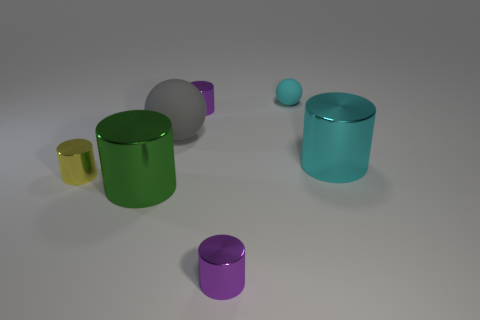What number of tiny things are both behind the big sphere and in front of the tiny rubber ball?
Provide a succinct answer. 1. What is the size of the yellow object that is the same shape as the green thing?
Offer a very short reply. Small. What number of large gray matte spheres are behind the large cylinder to the right of the tiny cylinder that is in front of the tiny yellow cylinder?
Make the answer very short. 1. The small shiny cylinder behind the cyan object that is on the right side of the small cyan matte sphere is what color?
Ensure brevity in your answer.  Purple. What number of other objects are the same material as the tiny cyan thing?
Provide a succinct answer. 1. How many things are behind the small yellow metallic cylinder in front of the big sphere?
Keep it short and to the point. 4. Do the large shiny thing behind the green cylinder and the tiny rubber thing right of the green object have the same color?
Your answer should be very brief. Yes. Are there fewer tiny yellow cylinders than large shiny cylinders?
Make the answer very short. Yes. There is a matte object behind the small cylinder behind the small yellow cylinder; what shape is it?
Give a very brief answer. Sphere. There is a purple thing behind the big metallic object that is in front of the tiny metallic thing left of the green metal object; what is its shape?
Give a very brief answer. Cylinder. 